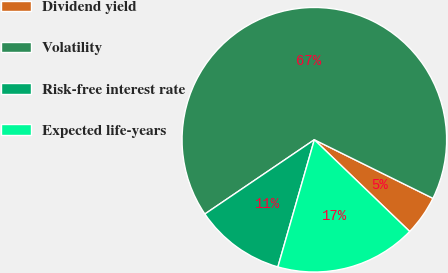<chart> <loc_0><loc_0><loc_500><loc_500><pie_chart><fcel>Dividend yield<fcel>Volatility<fcel>Risk-free interest rate<fcel>Expected life-years<nl><fcel>4.89%<fcel>66.79%<fcel>11.07%<fcel>17.25%<nl></chart> 